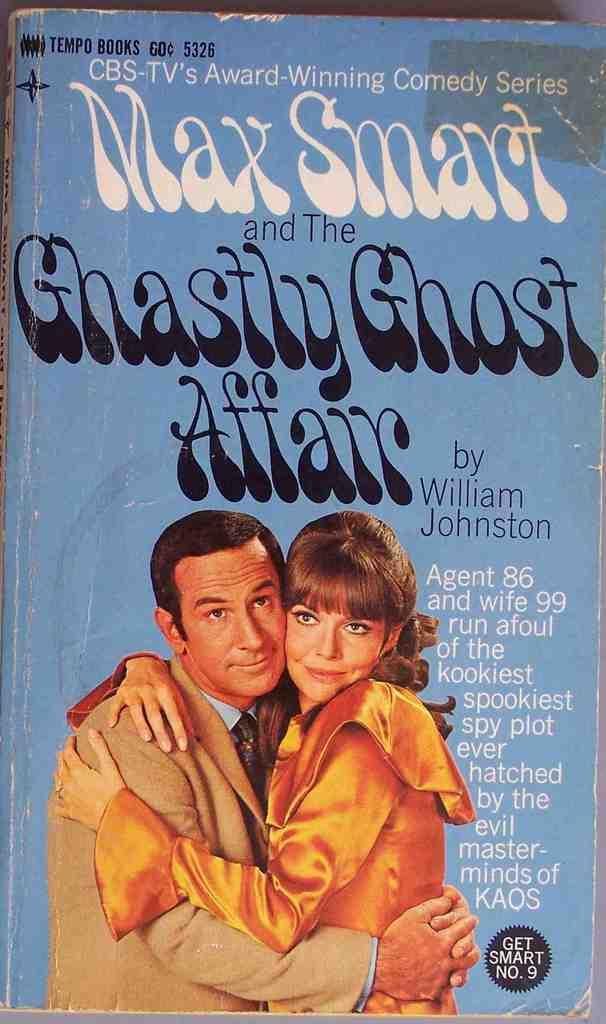Is this by william johnston?
Give a very brief answer. Yes. How much was this magazine?
Provide a short and direct response. 60 cents. 